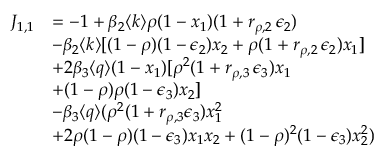Convert formula to latex. <formula><loc_0><loc_0><loc_500><loc_500>\begin{array} { r l } { J _ { 1 , 1 } } & { = - 1 + \beta _ { 2 } \langle k \rangle \rho ( 1 - x _ { 1 } ) ( 1 + r _ { \rho , 2 } \, \epsilon _ { 2 } ) } \\ & { - \beta _ { 2 } \langle k \rangle [ ( 1 - \rho ) ( 1 - \epsilon _ { 2 } ) x _ { 2 } + \rho ( 1 + r _ { \rho , 2 } \, \epsilon _ { 2 } ) x _ { 1 } ] } \\ & { + 2 \beta _ { 3 } \langle q \rangle ( 1 - x _ { 1 } ) [ \rho ^ { 2 } ( 1 + r _ { \rho , 3 } \, \epsilon _ { 3 } ) x _ { 1 } } \\ & { + ( 1 - \rho ) \rho ( 1 - \epsilon _ { 3 } ) x _ { 2 } ] } \\ & { - \beta _ { 3 } \langle q \rangle ( \rho ^ { 2 } ( 1 + r _ { \rho , 3 } \epsilon _ { 3 } ) x _ { 1 } ^ { 2 } } \\ & { + 2 \rho ( 1 - \rho ) ( 1 - \epsilon _ { 3 } ) x _ { 1 } x _ { 2 } + ( 1 - \rho ) ^ { 2 } ( 1 - \epsilon _ { 3 } ) x _ { 2 } ^ { 2 } ) } \end{array}</formula> 